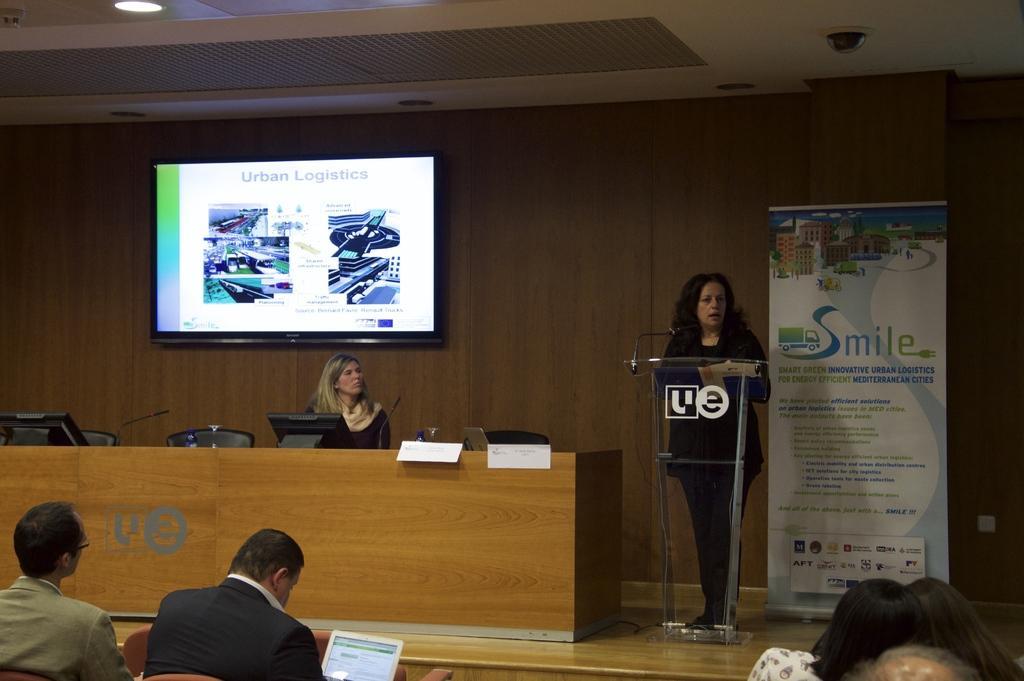Could you give a brief overview of what you see in this image? In this image I can see few people sitting on the chairs and one person with the laptop. In-front of these people I can see two people and the podium. There is a table in-front of one person and on the table I can see the monitors, papers and few objects. In the background I can see the banner and the screen to the wall. I can see the lights at the top. 